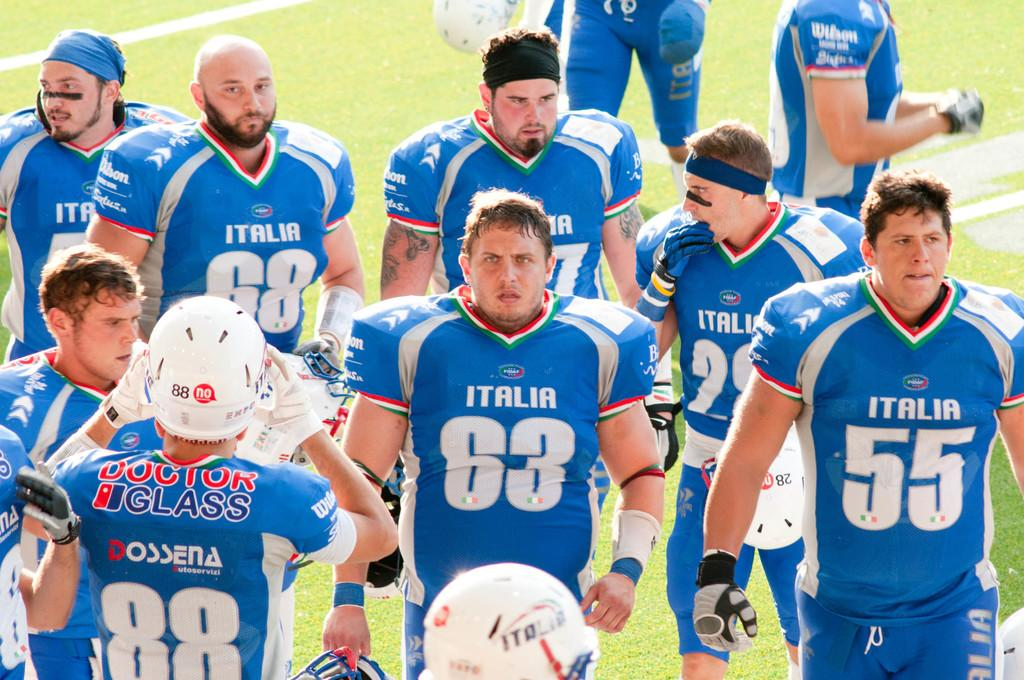<image>
Write a terse but informative summary of the picture. A team of football players all in blue tops with Italia on them look very unhappy as they walk off the field. 